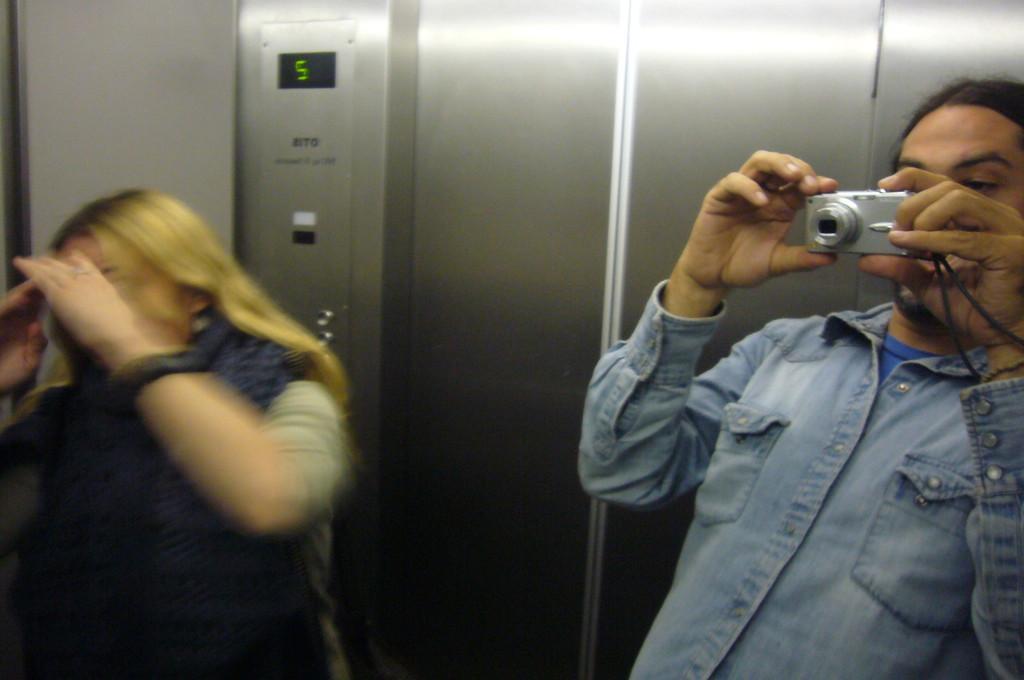Describe this image in one or two sentences. This picture is clicked inside an elevator. The man to the right corner is holding a camera in his hand and is about to click a photo. There is another woman to the left corner. Behind them there is digital display board and buttons. 